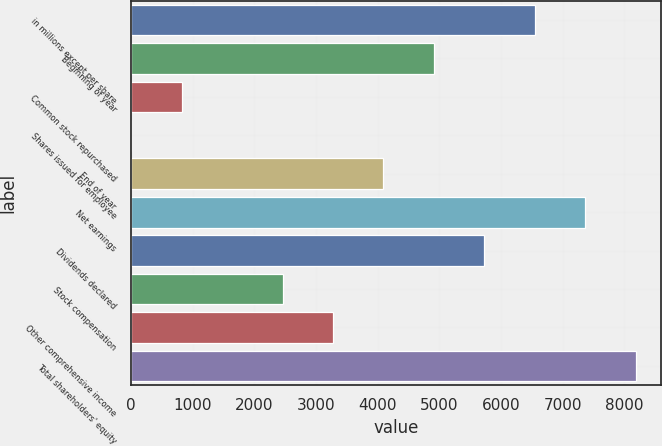Convert chart to OTSL. <chart><loc_0><loc_0><loc_500><loc_500><bar_chart><fcel>in millions except per share<fcel>Beginning of year<fcel>Common stock repurchased<fcel>Shares issued for employee<fcel>End of year<fcel>Net earnings<fcel>Dividends declared<fcel>Stock compensation<fcel>Other comprehensive income<fcel>Total shareholders' equity<nl><fcel>6549.8<fcel>4912.6<fcel>819.6<fcel>1<fcel>4094<fcel>7368.4<fcel>5731.2<fcel>2456.8<fcel>3275.4<fcel>8187<nl></chart> 